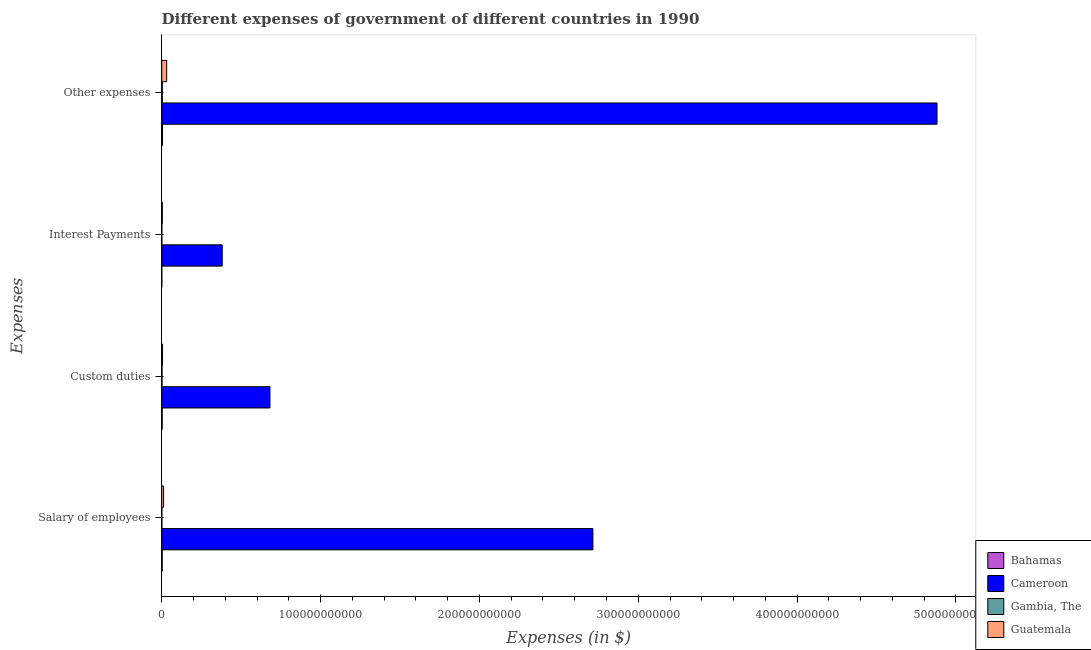Are the number of bars per tick equal to the number of legend labels?
Give a very brief answer. Yes. Are the number of bars on each tick of the Y-axis equal?
Provide a short and direct response. Yes. How many bars are there on the 2nd tick from the top?
Provide a short and direct response. 4. What is the label of the 1st group of bars from the top?
Offer a very short reply. Other expenses. What is the amount spent on interest payments in Guatemala?
Your response must be concise. 3.89e+08. Across all countries, what is the maximum amount spent on custom duties?
Provide a short and direct response. 6.81e+1. Across all countries, what is the minimum amount spent on custom duties?
Make the answer very short. 2.07e+08. In which country was the amount spent on custom duties maximum?
Your answer should be very brief. Cameroon. In which country was the amount spent on other expenses minimum?
Provide a succinct answer. Gambia, The. What is the total amount spent on custom duties in the graph?
Provide a succinct answer. 6.92e+1. What is the difference between the amount spent on custom duties in Bahamas and that in Gambia, The?
Your response must be concise. 8.17e+07. What is the difference between the amount spent on other expenses in Cameroon and the amount spent on custom duties in Guatemala?
Your response must be concise. 4.88e+11. What is the average amount spent on salary of employees per country?
Make the answer very short. 6.83e+1. What is the difference between the amount spent on custom duties and amount spent on other expenses in Gambia, The?
Make the answer very short. -1.81e+08. What is the ratio of the amount spent on custom duties in Cameroon to that in Guatemala?
Give a very brief answer. 130.28. Is the amount spent on other expenses in Guatemala less than that in Gambia, The?
Provide a succinct answer. No. What is the difference between the highest and the second highest amount spent on interest payments?
Provide a succinct answer. 3.77e+1. What is the difference between the highest and the lowest amount spent on custom duties?
Provide a short and direct response. 6.79e+1. Is it the case that in every country, the sum of the amount spent on salary of employees and amount spent on custom duties is greater than the sum of amount spent on other expenses and amount spent on interest payments?
Offer a terse response. No. What does the 3rd bar from the top in Custom duties represents?
Your answer should be very brief. Cameroon. What does the 4th bar from the bottom in Other expenses represents?
Offer a very short reply. Guatemala. Is it the case that in every country, the sum of the amount spent on salary of employees and amount spent on custom duties is greater than the amount spent on interest payments?
Your answer should be compact. Yes. How many bars are there?
Provide a short and direct response. 16. What is the difference between two consecutive major ticks on the X-axis?
Provide a succinct answer. 1.00e+11. Are the values on the major ticks of X-axis written in scientific E-notation?
Ensure brevity in your answer.  No. Does the graph contain grids?
Ensure brevity in your answer.  No. Where does the legend appear in the graph?
Offer a terse response. Bottom right. How many legend labels are there?
Make the answer very short. 4. What is the title of the graph?
Your answer should be very brief. Different expenses of government of different countries in 1990. Does "Liberia" appear as one of the legend labels in the graph?
Keep it short and to the point. No. What is the label or title of the X-axis?
Provide a succinct answer. Expenses (in $). What is the label or title of the Y-axis?
Your response must be concise. Expenses. What is the Expenses (in $) in Bahamas in Salary of employees?
Your answer should be compact. 2.89e+08. What is the Expenses (in $) of Cameroon in Salary of employees?
Your answer should be very brief. 2.71e+11. What is the Expenses (in $) of Gambia, The in Salary of employees?
Your answer should be compact. 1.23e+08. What is the Expenses (in $) of Guatemala in Salary of employees?
Provide a succinct answer. 1.17e+09. What is the Expenses (in $) in Bahamas in Custom duties?
Your response must be concise. 2.89e+08. What is the Expenses (in $) of Cameroon in Custom duties?
Offer a terse response. 6.81e+1. What is the Expenses (in $) of Gambia, The in Custom duties?
Make the answer very short. 2.07e+08. What is the Expenses (in $) in Guatemala in Custom duties?
Make the answer very short. 5.23e+08. What is the Expenses (in $) in Bahamas in Interest Payments?
Keep it short and to the point. 6.18e+07. What is the Expenses (in $) in Cameroon in Interest Payments?
Give a very brief answer. 3.81e+1. What is the Expenses (in $) in Gambia, The in Interest Payments?
Your response must be concise. 9.17e+07. What is the Expenses (in $) in Guatemala in Interest Payments?
Make the answer very short. 3.89e+08. What is the Expenses (in $) of Bahamas in Other expenses?
Ensure brevity in your answer.  5.26e+08. What is the Expenses (in $) of Cameroon in Other expenses?
Keep it short and to the point. 4.88e+11. What is the Expenses (in $) of Gambia, The in Other expenses?
Your response must be concise. 3.88e+08. What is the Expenses (in $) of Guatemala in Other expenses?
Ensure brevity in your answer.  3.13e+09. Across all Expenses, what is the maximum Expenses (in $) in Bahamas?
Your answer should be compact. 5.26e+08. Across all Expenses, what is the maximum Expenses (in $) of Cameroon?
Your answer should be very brief. 4.88e+11. Across all Expenses, what is the maximum Expenses (in $) in Gambia, The?
Your answer should be compact. 3.88e+08. Across all Expenses, what is the maximum Expenses (in $) of Guatemala?
Offer a terse response. 3.13e+09. Across all Expenses, what is the minimum Expenses (in $) in Bahamas?
Your answer should be very brief. 6.18e+07. Across all Expenses, what is the minimum Expenses (in $) of Cameroon?
Offer a very short reply. 3.81e+1. Across all Expenses, what is the minimum Expenses (in $) of Gambia, The?
Your answer should be very brief. 9.17e+07. Across all Expenses, what is the minimum Expenses (in $) of Guatemala?
Offer a very short reply. 3.89e+08. What is the total Expenses (in $) in Bahamas in the graph?
Ensure brevity in your answer.  1.17e+09. What is the total Expenses (in $) of Cameroon in the graph?
Your answer should be compact. 8.66e+11. What is the total Expenses (in $) in Gambia, The in the graph?
Give a very brief answer. 8.10e+08. What is the total Expenses (in $) in Guatemala in the graph?
Offer a very short reply. 5.22e+09. What is the difference between the Expenses (in $) in Cameroon in Salary of employees and that in Custom duties?
Your response must be concise. 2.03e+11. What is the difference between the Expenses (in $) in Gambia, The in Salary of employees and that in Custom duties?
Your answer should be compact. -8.43e+07. What is the difference between the Expenses (in $) of Guatemala in Salary of employees and that in Custom duties?
Offer a terse response. 6.49e+08. What is the difference between the Expenses (in $) of Bahamas in Salary of employees and that in Interest Payments?
Offer a terse response. 2.27e+08. What is the difference between the Expenses (in $) of Cameroon in Salary of employees and that in Interest Payments?
Give a very brief answer. 2.33e+11. What is the difference between the Expenses (in $) of Gambia, The in Salary of employees and that in Interest Payments?
Your answer should be very brief. 3.12e+07. What is the difference between the Expenses (in $) in Guatemala in Salary of employees and that in Interest Payments?
Provide a succinct answer. 7.83e+08. What is the difference between the Expenses (in $) in Bahamas in Salary of employees and that in Other expenses?
Provide a short and direct response. -2.37e+08. What is the difference between the Expenses (in $) of Cameroon in Salary of employees and that in Other expenses?
Ensure brevity in your answer.  -2.17e+11. What is the difference between the Expenses (in $) of Gambia, The in Salary of employees and that in Other expenses?
Your answer should be very brief. -2.65e+08. What is the difference between the Expenses (in $) of Guatemala in Salary of employees and that in Other expenses?
Offer a terse response. -1.96e+09. What is the difference between the Expenses (in $) of Bahamas in Custom duties and that in Interest Payments?
Your response must be concise. 2.27e+08. What is the difference between the Expenses (in $) of Cameroon in Custom duties and that in Interest Payments?
Ensure brevity in your answer.  3.01e+1. What is the difference between the Expenses (in $) in Gambia, The in Custom duties and that in Interest Payments?
Ensure brevity in your answer.  1.16e+08. What is the difference between the Expenses (in $) of Guatemala in Custom duties and that in Interest Payments?
Your response must be concise. 1.34e+08. What is the difference between the Expenses (in $) of Bahamas in Custom duties and that in Other expenses?
Keep it short and to the point. -2.37e+08. What is the difference between the Expenses (in $) in Cameroon in Custom duties and that in Other expenses?
Offer a very short reply. -4.20e+11. What is the difference between the Expenses (in $) of Gambia, The in Custom duties and that in Other expenses?
Keep it short and to the point. -1.81e+08. What is the difference between the Expenses (in $) of Guatemala in Custom duties and that in Other expenses?
Provide a succinct answer. -2.61e+09. What is the difference between the Expenses (in $) of Bahamas in Interest Payments and that in Other expenses?
Make the answer very short. -4.64e+08. What is the difference between the Expenses (in $) of Cameroon in Interest Payments and that in Other expenses?
Give a very brief answer. -4.50e+11. What is the difference between the Expenses (in $) in Gambia, The in Interest Payments and that in Other expenses?
Give a very brief answer. -2.96e+08. What is the difference between the Expenses (in $) in Guatemala in Interest Payments and that in Other expenses?
Provide a succinct answer. -2.74e+09. What is the difference between the Expenses (in $) in Bahamas in Salary of employees and the Expenses (in $) in Cameroon in Custom duties?
Make the answer very short. -6.79e+1. What is the difference between the Expenses (in $) in Bahamas in Salary of employees and the Expenses (in $) in Gambia, The in Custom duties?
Provide a succinct answer. 8.19e+07. What is the difference between the Expenses (in $) in Bahamas in Salary of employees and the Expenses (in $) in Guatemala in Custom duties?
Your response must be concise. -2.34e+08. What is the difference between the Expenses (in $) in Cameroon in Salary of employees and the Expenses (in $) in Gambia, The in Custom duties?
Provide a short and direct response. 2.71e+11. What is the difference between the Expenses (in $) of Cameroon in Salary of employees and the Expenses (in $) of Guatemala in Custom duties?
Provide a short and direct response. 2.71e+11. What is the difference between the Expenses (in $) in Gambia, The in Salary of employees and the Expenses (in $) in Guatemala in Custom duties?
Your response must be concise. -4.00e+08. What is the difference between the Expenses (in $) of Bahamas in Salary of employees and the Expenses (in $) of Cameroon in Interest Payments?
Your answer should be very brief. -3.78e+1. What is the difference between the Expenses (in $) of Bahamas in Salary of employees and the Expenses (in $) of Gambia, The in Interest Payments?
Your answer should be very brief. 1.97e+08. What is the difference between the Expenses (in $) of Bahamas in Salary of employees and the Expenses (in $) of Guatemala in Interest Payments?
Offer a very short reply. -9.98e+07. What is the difference between the Expenses (in $) in Cameroon in Salary of employees and the Expenses (in $) in Gambia, The in Interest Payments?
Provide a succinct answer. 2.71e+11. What is the difference between the Expenses (in $) of Cameroon in Salary of employees and the Expenses (in $) of Guatemala in Interest Payments?
Your answer should be very brief. 2.71e+11. What is the difference between the Expenses (in $) in Gambia, The in Salary of employees and the Expenses (in $) in Guatemala in Interest Payments?
Keep it short and to the point. -2.66e+08. What is the difference between the Expenses (in $) of Bahamas in Salary of employees and the Expenses (in $) of Cameroon in Other expenses?
Give a very brief answer. -4.88e+11. What is the difference between the Expenses (in $) of Bahamas in Salary of employees and the Expenses (in $) of Gambia, The in Other expenses?
Make the answer very short. -9.91e+07. What is the difference between the Expenses (in $) in Bahamas in Salary of employees and the Expenses (in $) in Guatemala in Other expenses?
Make the answer very short. -2.84e+09. What is the difference between the Expenses (in $) of Cameroon in Salary of employees and the Expenses (in $) of Gambia, The in Other expenses?
Ensure brevity in your answer.  2.71e+11. What is the difference between the Expenses (in $) in Cameroon in Salary of employees and the Expenses (in $) in Guatemala in Other expenses?
Provide a succinct answer. 2.68e+11. What is the difference between the Expenses (in $) of Gambia, The in Salary of employees and the Expenses (in $) of Guatemala in Other expenses?
Offer a very short reply. -3.01e+09. What is the difference between the Expenses (in $) of Bahamas in Custom duties and the Expenses (in $) of Cameroon in Interest Payments?
Keep it short and to the point. -3.78e+1. What is the difference between the Expenses (in $) in Bahamas in Custom duties and the Expenses (in $) in Gambia, The in Interest Payments?
Give a very brief answer. 1.97e+08. What is the difference between the Expenses (in $) of Bahamas in Custom duties and the Expenses (in $) of Guatemala in Interest Payments?
Provide a succinct answer. -1.00e+08. What is the difference between the Expenses (in $) of Cameroon in Custom duties and the Expenses (in $) of Gambia, The in Interest Payments?
Your response must be concise. 6.80e+1. What is the difference between the Expenses (in $) of Cameroon in Custom duties and the Expenses (in $) of Guatemala in Interest Payments?
Keep it short and to the point. 6.78e+1. What is the difference between the Expenses (in $) in Gambia, The in Custom duties and the Expenses (in $) in Guatemala in Interest Payments?
Keep it short and to the point. -1.82e+08. What is the difference between the Expenses (in $) of Bahamas in Custom duties and the Expenses (in $) of Cameroon in Other expenses?
Ensure brevity in your answer.  -4.88e+11. What is the difference between the Expenses (in $) of Bahamas in Custom duties and the Expenses (in $) of Gambia, The in Other expenses?
Give a very brief answer. -9.93e+07. What is the difference between the Expenses (in $) in Bahamas in Custom duties and the Expenses (in $) in Guatemala in Other expenses?
Offer a very short reply. -2.84e+09. What is the difference between the Expenses (in $) of Cameroon in Custom duties and the Expenses (in $) of Gambia, The in Other expenses?
Make the answer very short. 6.78e+1. What is the difference between the Expenses (in $) in Cameroon in Custom duties and the Expenses (in $) in Guatemala in Other expenses?
Ensure brevity in your answer.  6.50e+1. What is the difference between the Expenses (in $) in Gambia, The in Custom duties and the Expenses (in $) in Guatemala in Other expenses?
Provide a succinct answer. -2.93e+09. What is the difference between the Expenses (in $) of Bahamas in Interest Payments and the Expenses (in $) of Cameroon in Other expenses?
Provide a succinct answer. -4.88e+11. What is the difference between the Expenses (in $) in Bahamas in Interest Payments and the Expenses (in $) in Gambia, The in Other expenses?
Your answer should be compact. -3.26e+08. What is the difference between the Expenses (in $) in Bahamas in Interest Payments and the Expenses (in $) in Guatemala in Other expenses?
Provide a succinct answer. -3.07e+09. What is the difference between the Expenses (in $) of Cameroon in Interest Payments and the Expenses (in $) of Gambia, The in Other expenses?
Your answer should be very brief. 3.77e+1. What is the difference between the Expenses (in $) of Cameroon in Interest Payments and the Expenses (in $) of Guatemala in Other expenses?
Your response must be concise. 3.49e+1. What is the difference between the Expenses (in $) of Gambia, The in Interest Payments and the Expenses (in $) of Guatemala in Other expenses?
Provide a short and direct response. -3.04e+09. What is the average Expenses (in $) in Bahamas per Expenses?
Your response must be concise. 2.91e+08. What is the average Expenses (in $) of Cameroon per Expenses?
Keep it short and to the point. 2.16e+11. What is the average Expenses (in $) in Gambia, The per Expenses?
Keep it short and to the point. 2.03e+08. What is the average Expenses (in $) of Guatemala per Expenses?
Your response must be concise. 1.30e+09. What is the difference between the Expenses (in $) of Bahamas and Expenses (in $) of Cameroon in Salary of employees?
Offer a terse response. -2.71e+11. What is the difference between the Expenses (in $) of Bahamas and Expenses (in $) of Gambia, The in Salary of employees?
Your answer should be compact. 1.66e+08. What is the difference between the Expenses (in $) of Bahamas and Expenses (in $) of Guatemala in Salary of employees?
Provide a short and direct response. -8.83e+08. What is the difference between the Expenses (in $) in Cameroon and Expenses (in $) in Gambia, The in Salary of employees?
Your response must be concise. 2.71e+11. What is the difference between the Expenses (in $) in Cameroon and Expenses (in $) in Guatemala in Salary of employees?
Your answer should be very brief. 2.70e+11. What is the difference between the Expenses (in $) in Gambia, The and Expenses (in $) in Guatemala in Salary of employees?
Offer a terse response. -1.05e+09. What is the difference between the Expenses (in $) in Bahamas and Expenses (in $) in Cameroon in Custom duties?
Offer a very short reply. -6.79e+1. What is the difference between the Expenses (in $) in Bahamas and Expenses (in $) in Gambia, The in Custom duties?
Your answer should be compact. 8.17e+07. What is the difference between the Expenses (in $) in Bahamas and Expenses (in $) in Guatemala in Custom duties?
Give a very brief answer. -2.34e+08. What is the difference between the Expenses (in $) in Cameroon and Expenses (in $) in Gambia, The in Custom duties?
Your answer should be compact. 6.79e+1. What is the difference between the Expenses (in $) of Cameroon and Expenses (in $) of Guatemala in Custom duties?
Offer a very short reply. 6.76e+1. What is the difference between the Expenses (in $) in Gambia, The and Expenses (in $) in Guatemala in Custom duties?
Provide a succinct answer. -3.16e+08. What is the difference between the Expenses (in $) of Bahamas and Expenses (in $) of Cameroon in Interest Payments?
Your response must be concise. -3.80e+1. What is the difference between the Expenses (in $) of Bahamas and Expenses (in $) of Gambia, The in Interest Payments?
Keep it short and to the point. -2.99e+07. What is the difference between the Expenses (in $) of Bahamas and Expenses (in $) of Guatemala in Interest Payments?
Make the answer very short. -3.27e+08. What is the difference between the Expenses (in $) in Cameroon and Expenses (in $) in Gambia, The in Interest Payments?
Offer a terse response. 3.80e+1. What is the difference between the Expenses (in $) in Cameroon and Expenses (in $) in Guatemala in Interest Payments?
Provide a succinct answer. 3.77e+1. What is the difference between the Expenses (in $) in Gambia, The and Expenses (in $) in Guatemala in Interest Payments?
Provide a short and direct response. -2.97e+08. What is the difference between the Expenses (in $) in Bahamas and Expenses (in $) in Cameroon in Other expenses?
Make the answer very short. -4.88e+11. What is the difference between the Expenses (in $) in Bahamas and Expenses (in $) in Gambia, The in Other expenses?
Provide a short and direct response. 1.38e+08. What is the difference between the Expenses (in $) of Bahamas and Expenses (in $) of Guatemala in Other expenses?
Keep it short and to the point. -2.61e+09. What is the difference between the Expenses (in $) in Cameroon and Expenses (in $) in Gambia, The in Other expenses?
Ensure brevity in your answer.  4.88e+11. What is the difference between the Expenses (in $) of Cameroon and Expenses (in $) of Guatemala in Other expenses?
Give a very brief answer. 4.85e+11. What is the difference between the Expenses (in $) of Gambia, The and Expenses (in $) of Guatemala in Other expenses?
Give a very brief answer. -2.75e+09. What is the ratio of the Expenses (in $) in Cameroon in Salary of employees to that in Custom duties?
Make the answer very short. 3.98. What is the ratio of the Expenses (in $) in Gambia, The in Salary of employees to that in Custom duties?
Your answer should be very brief. 0.59. What is the ratio of the Expenses (in $) of Guatemala in Salary of employees to that in Custom duties?
Give a very brief answer. 2.24. What is the ratio of the Expenses (in $) in Bahamas in Salary of employees to that in Interest Payments?
Your answer should be very brief. 4.68. What is the ratio of the Expenses (in $) of Cameroon in Salary of employees to that in Interest Payments?
Give a very brief answer. 7.13. What is the ratio of the Expenses (in $) of Gambia, The in Salary of employees to that in Interest Payments?
Make the answer very short. 1.34. What is the ratio of the Expenses (in $) of Guatemala in Salary of employees to that in Interest Payments?
Ensure brevity in your answer.  3.01. What is the ratio of the Expenses (in $) of Bahamas in Salary of employees to that in Other expenses?
Your answer should be compact. 0.55. What is the ratio of the Expenses (in $) of Cameroon in Salary of employees to that in Other expenses?
Ensure brevity in your answer.  0.56. What is the ratio of the Expenses (in $) in Gambia, The in Salary of employees to that in Other expenses?
Provide a short and direct response. 0.32. What is the ratio of the Expenses (in $) in Guatemala in Salary of employees to that in Other expenses?
Your answer should be compact. 0.37. What is the ratio of the Expenses (in $) in Bahamas in Custom duties to that in Interest Payments?
Your response must be concise. 4.67. What is the ratio of the Expenses (in $) of Cameroon in Custom duties to that in Interest Payments?
Your answer should be very brief. 1.79. What is the ratio of the Expenses (in $) of Gambia, The in Custom duties to that in Interest Payments?
Provide a short and direct response. 2.26. What is the ratio of the Expenses (in $) of Guatemala in Custom duties to that in Interest Payments?
Your response must be concise. 1.34. What is the ratio of the Expenses (in $) in Bahamas in Custom duties to that in Other expenses?
Your response must be concise. 0.55. What is the ratio of the Expenses (in $) in Cameroon in Custom duties to that in Other expenses?
Your response must be concise. 0.14. What is the ratio of the Expenses (in $) in Gambia, The in Custom duties to that in Other expenses?
Offer a terse response. 0.53. What is the ratio of the Expenses (in $) in Guatemala in Custom duties to that in Other expenses?
Provide a succinct answer. 0.17. What is the ratio of the Expenses (in $) in Bahamas in Interest Payments to that in Other expenses?
Your answer should be compact. 0.12. What is the ratio of the Expenses (in $) in Cameroon in Interest Payments to that in Other expenses?
Provide a succinct answer. 0.08. What is the ratio of the Expenses (in $) in Gambia, The in Interest Payments to that in Other expenses?
Offer a terse response. 0.24. What is the ratio of the Expenses (in $) of Guatemala in Interest Payments to that in Other expenses?
Offer a terse response. 0.12. What is the difference between the highest and the second highest Expenses (in $) in Bahamas?
Your answer should be very brief. 2.37e+08. What is the difference between the highest and the second highest Expenses (in $) in Cameroon?
Offer a very short reply. 2.17e+11. What is the difference between the highest and the second highest Expenses (in $) of Gambia, The?
Ensure brevity in your answer.  1.81e+08. What is the difference between the highest and the second highest Expenses (in $) of Guatemala?
Make the answer very short. 1.96e+09. What is the difference between the highest and the lowest Expenses (in $) of Bahamas?
Ensure brevity in your answer.  4.64e+08. What is the difference between the highest and the lowest Expenses (in $) of Cameroon?
Keep it short and to the point. 4.50e+11. What is the difference between the highest and the lowest Expenses (in $) in Gambia, The?
Provide a succinct answer. 2.96e+08. What is the difference between the highest and the lowest Expenses (in $) of Guatemala?
Your answer should be very brief. 2.74e+09. 